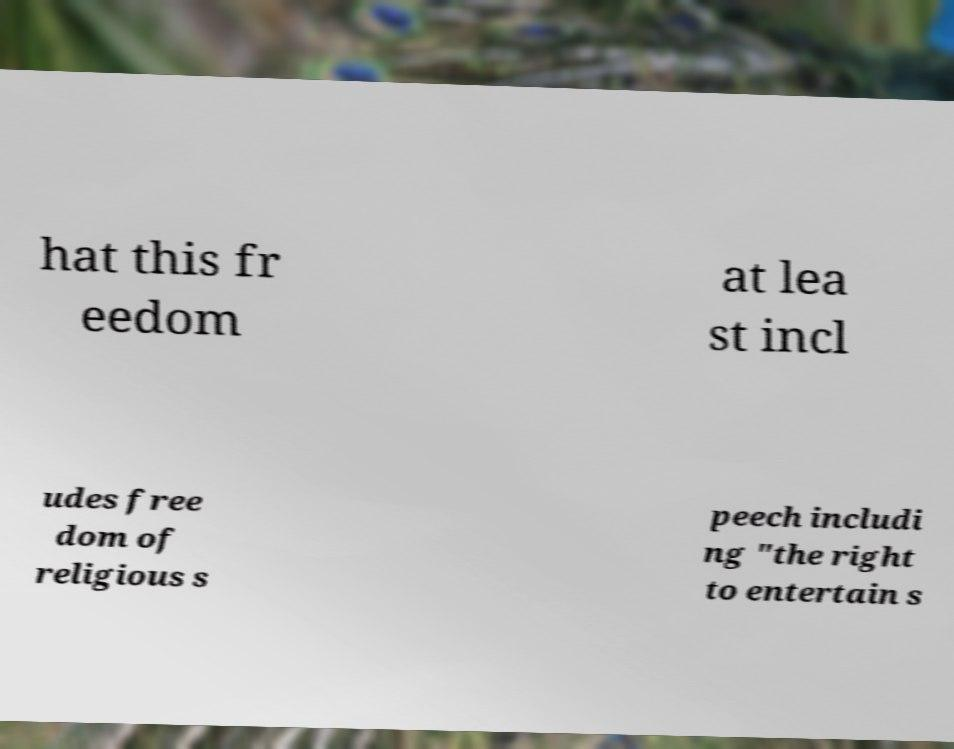I need the written content from this picture converted into text. Can you do that? hat this fr eedom at lea st incl udes free dom of religious s peech includi ng "the right to entertain s 